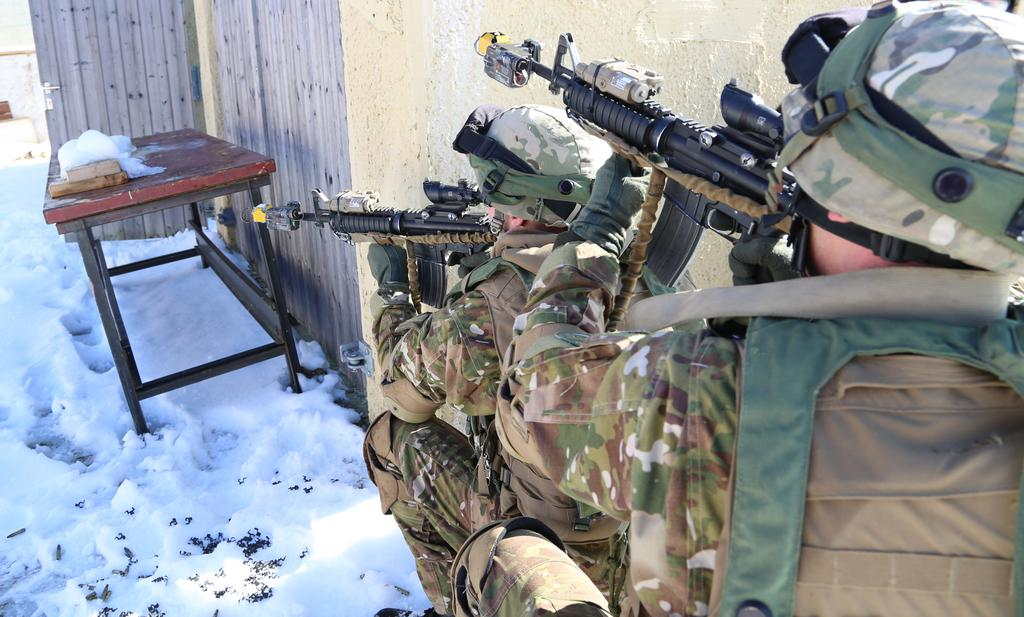What is covering the ground in the image? There is snow on the ground. What is placed on top of the snow? There is a table on the snow. What are the soldiers in the image doing? The soldiers are holding guns in the image. What is behind the soldiers? The soldiers are in front of a wall. What is a feature of the wall? There is a door attached to the wall. How many clocks can be seen hanging on the wall in the image? There are no clocks visible in the image; the focus is on the soldiers, table, and wall. What type of crown is worn by the soldiers in the image? There are no crowns present in the image; the soldiers are holding guns and standing in front of a wall. 